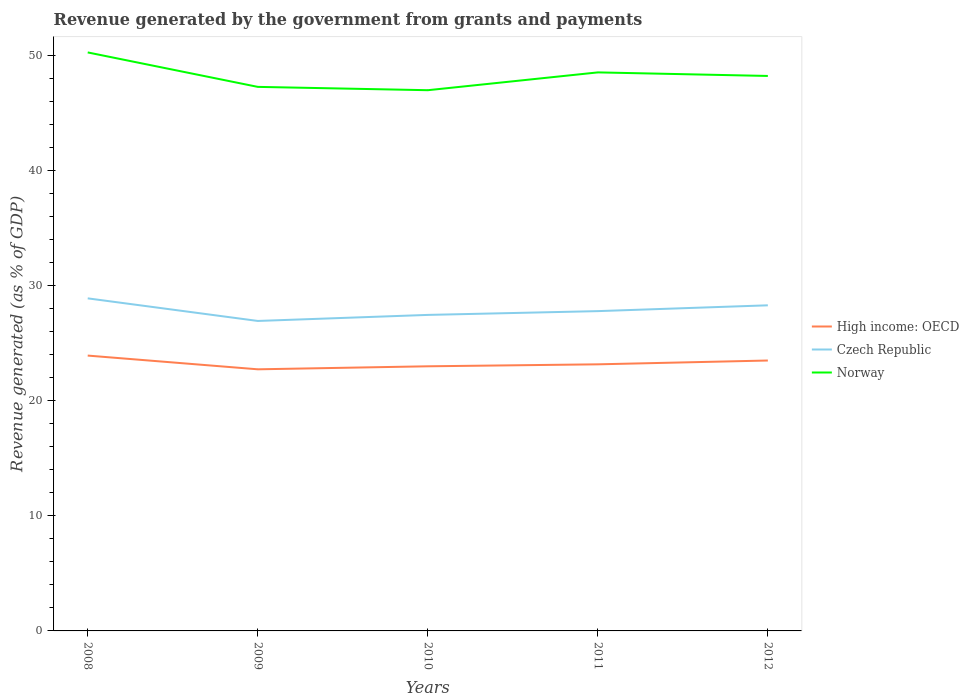Is the number of lines equal to the number of legend labels?
Make the answer very short. Yes. Across all years, what is the maximum revenue generated by the government in Norway?
Your answer should be very brief. 46.94. What is the total revenue generated by the government in Czech Republic in the graph?
Ensure brevity in your answer.  1.11. What is the difference between the highest and the second highest revenue generated by the government in High income: OECD?
Offer a terse response. 1.19. What is the difference between the highest and the lowest revenue generated by the government in Norway?
Your answer should be very brief. 2. Is the revenue generated by the government in Czech Republic strictly greater than the revenue generated by the government in High income: OECD over the years?
Ensure brevity in your answer.  No. How many lines are there?
Your answer should be compact. 3. How many years are there in the graph?
Ensure brevity in your answer.  5. Are the values on the major ticks of Y-axis written in scientific E-notation?
Provide a succinct answer. No. Does the graph contain grids?
Keep it short and to the point. No. How are the legend labels stacked?
Ensure brevity in your answer.  Vertical. What is the title of the graph?
Keep it short and to the point. Revenue generated by the government from grants and payments. Does "Korea (Democratic)" appear as one of the legend labels in the graph?
Provide a short and direct response. No. What is the label or title of the X-axis?
Your response must be concise. Years. What is the label or title of the Y-axis?
Offer a very short reply. Revenue generated (as % of GDP). What is the Revenue generated (as % of GDP) of High income: OECD in 2008?
Keep it short and to the point. 23.9. What is the Revenue generated (as % of GDP) of Czech Republic in 2008?
Your answer should be very brief. 28.87. What is the Revenue generated (as % of GDP) of Norway in 2008?
Provide a short and direct response. 50.23. What is the Revenue generated (as % of GDP) in High income: OECD in 2009?
Your response must be concise. 22.71. What is the Revenue generated (as % of GDP) of Czech Republic in 2009?
Ensure brevity in your answer.  26.91. What is the Revenue generated (as % of GDP) in Norway in 2009?
Offer a very short reply. 47.23. What is the Revenue generated (as % of GDP) of High income: OECD in 2010?
Your answer should be very brief. 22.97. What is the Revenue generated (as % of GDP) of Czech Republic in 2010?
Ensure brevity in your answer.  27.44. What is the Revenue generated (as % of GDP) of Norway in 2010?
Provide a succinct answer. 46.94. What is the Revenue generated (as % of GDP) in High income: OECD in 2011?
Your response must be concise. 23.15. What is the Revenue generated (as % of GDP) of Czech Republic in 2011?
Give a very brief answer. 27.76. What is the Revenue generated (as % of GDP) in Norway in 2011?
Ensure brevity in your answer.  48.49. What is the Revenue generated (as % of GDP) in High income: OECD in 2012?
Your answer should be very brief. 23.48. What is the Revenue generated (as % of GDP) of Czech Republic in 2012?
Ensure brevity in your answer.  28.27. What is the Revenue generated (as % of GDP) in Norway in 2012?
Provide a succinct answer. 48.18. Across all years, what is the maximum Revenue generated (as % of GDP) of High income: OECD?
Ensure brevity in your answer.  23.9. Across all years, what is the maximum Revenue generated (as % of GDP) in Czech Republic?
Your answer should be compact. 28.87. Across all years, what is the maximum Revenue generated (as % of GDP) in Norway?
Ensure brevity in your answer.  50.23. Across all years, what is the minimum Revenue generated (as % of GDP) of High income: OECD?
Your response must be concise. 22.71. Across all years, what is the minimum Revenue generated (as % of GDP) of Czech Republic?
Your response must be concise. 26.91. Across all years, what is the minimum Revenue generated (as % of GDP) in Norway?
Provide a short and direct response. 46.94. What is the total Revenue generated (as % of GDP) in High income: OECD in the graph?
Offer a terse response. 116.21. What is the total Revenue generated (as % of GDP) of Czech Republic in the graph?
Your answer should be compact. 139.26. What is the total Revenue generated (as % of GDP) of Norway in the graph?
Keep it short and to the point. 241.08. What is the difference between the Revenue generated (as % of GDP) in High income: OECD in 2008 and that in 2009?
Your answer should be compact. 1.19. What is the difference between the Revenue generated (as % of GDP) in Czech Republic in 2008 and that in 2009?
Keep it short and to the point. 1.96. What is the difference between the Revenue generated (as % of GDP) in Norway in 2008 and that in 2009?
Offer a terse response. 2.99. What is the difference between the Revenue generated (as % of GDP) in High income: OECD in 2008 and that in 2010?
Provide a short and direct response. 0.93. What is the difference between the Revenue generated (as % of GDP) of Czech Republic in 2008 and that in 2010?
Offer a very short reply. 1.44. What is the difference between the Revenue generated (as % of GDP) of Norway in 2008 and that in 2010?
Your response must be concise. 3.28. What is the difference between the Revenue generated (as % of GDP) of High income: OECD in 2008 and that in 2011?
Give a very brief answer. 0.76. What is the difference between the Revenue generated (as % of GDP) in Czech Republic in 2008 and that in 2011?
Keep it short and to the point. 1.11. What is the difference between the Revenue generated (as % of GDP) of Norway in 2008 and that in 2011?
Provide a short and direct response. 1.73. What is the difference between the Revenue generated (as % of GDP) of High income: OECD in 2008 and that in 2012?
Your response must be concise. 0.43. What is the difference between the Revenue generated (as % of GDP) in Czech Republic in 2008 and that in 2012?
Your answer should be very brief. 0.6. What is the difference between the Revenue generated (as % of GDP) in Norway in 2008 and that in 2012?
Provide a short and direct response. 2.04. What is the difference between the Revenue generated (as % of GDP) of High income: OECD in 2009 and that in 2010?
Offer a very short reply. -0.26. What is the difference between the Revenue generated (as % of GDP) in Czech Republic in 2009 and that in 2010?
Your answer should be compact. -0.53. What is the difference between the Revenue generated (as % of GDP) of Norway in 2009 and that in 2010?
Provide a short and direct response. 0.29. What is the difference between the Revenue generated (as % of GDP) in High income: OECD in 2009 and that in 2011?
Your answer should be very brief. -0.43. What is the difference between the Revenue generated (as % of GDP) in Czech Republic in 2009 and that in 2011?
Ensure brevity in your answer.  -0.85. What is the difference between the Revenue generated (as % of GDP) of Norway in 2009 and that in 2011?
Provide a succinct answer. -1.26. What is the difference between the Revenue generated (as % of GDP) in High income: OECD in 2009 and that in 2012?
Provide a succinct answer. -0.76. What is the difference between the Revenue generated (as % of GDP) of Czech Republic in 2009 and that in 2012?
Keep it short and to the point. -1.36. What is the difference between the Revenue generated (as % of GDP) in Norway in 2009 and that in 2012?
Offer a terse response. -0.95. What is the difference between the Revenue generated (as % of GDP) of High income: OECD in 2010 and that in 2011?
Provide a succinct answer. -0.17. What is the difference between the Revenue generated (as % of GDP) in Czech Republic in 2010 and that in 2011?
Make the answer very short. -0.33. What is the difference between the Revenue generated (as % of GDP) in Norway in 2010 and that in 2011?
Ensure brevity in your answer.  -1.55. What is the difference between the Revenue generated (as % of GDP) in High income: OECD in 2010 and that in 2012?
Your answer should be compact. -0.5. What is the difference between the Revenue generated (as % of GDP) in Czech Republic in 2010 and that in 2012?
Your answer should be compact. -0.83. What is the difference between the Revenue generated (as % of GDP) of Norway in 2010 and that in 2012?
Give a very brief answer. -1.24. What is the difference between the Revenue generated (as % of GDP) of High income: OECD in 2011 and that in 2012?
Your answer should be compact. -0.33. What is the difference between the Revenue generated (as % of GDP) of Czech Republic in 2011 and that in 2012?
Provide a succinct answer. -0.51. What is the difference between the Revenue generated (as % of GDP) of Norway in 2011 and that in 2012?
Your answer should be very brief. 0.31. What is the difference between the Revenue generated (as % of GDP) in High income: OECD in 2008 and the Revenue generated (as % of GDP) in Czech Republic in 2009?
Your answer should be very brief. -3.01. What is the difference between the Revenue generated (as % of GDP) in High income: OECD in 2008 and the Revenue generated (as % of GDP) in Norway in 2009?
Provide a short and direct response. -23.33. What is the difference between the Revenue generated (as % of GDP) of Czech Republic in 2008 and the Revenue generated (as % of GDP) of Norway in 2009?
Offer a terse response. -18.36. What is the difference between the Revenue generated (as % of GDP) of High income: OECD in 2008 and the Revenue generated (as % of GDP) of Czech Republic in 2010?
Offer a very short reply. -3.53. What is the difference between the Revenue generated (as % of GDP) of High income: OECD in 2008 and the Revenue generated (as % of GDP) of Norway in 2010?
Your response must be concise. -23.04. What is the difference between the Revenue generated (as % of GDP) in Czech Republic in 2008 and the Revenue generated (as % of GDP) in Norway in 2010?
Offer a very short reply. -18.07. What is the difference between the Revenue generated (as % of GDP) in High income: OECD in 2008 and the Revenue generated (as % of GDP) in Czech Republic in 2011?
Give a very brief answer. -3.86. What is the difference between the Revenue generated (as % of GDP) in High income: OECD in 2008 and the Revenue generated (as % of GDP) in Norway in 2011?
Ensure brevity in your answer.  -24.59. What is the difference between the Revenue generated (as % of GDP) of Czech Republic in 2008 and the Revenue generated (as % of GDP) of Norway in 2011?
Make the answer very short. -19.62. What is the difference between the Revenue generated (as % of GDP) of High income: OECD in 2008 and the Revenue generated (as % of GDP) of Czech Republic in 2012?
Provide a short and direct response. -4.36. What is the difference between the Revenue generated (as % of GDP) of High income: OECD in 2008 and the Revenue generated (as % of GDP) of Norway in 2012?
Offer a very short reply. -24.28. What is the difference between the Revenue generated (as % of GDP) in Czech Republic in 2008 and the Revenue generated (as % of GDP) in Norway in 2012?
Ensure brevity in your answer.  -19.31. What is the difference between the Revenue generated (as % of GDP) of High income: OECD in 2009 and the Revenue generated (as % of GDP) of Czech Republic in 2010?
Keep it short and to the point. -4.72. What is the difference between the Revenue generated (as % of GDP) in High income: OECD in 2009 and the Revenue generated (as % of GDP) in Norway in 2010?
Provide a succinct answer. -24.23. What is the difference between the Revenue generated (as % of GDP) of Czech Republic in 2009 and the Revenue generated (as % of GDP) of Norway in 2010?
Your response must be concise. -20.03. What is the difference between the Revenue generated (as % of GDP) of High income: OECD in 2009 and the Revenue generated (as % of GDP) of Czech Republic in 2011?
Provide a succinct answer. -5.05. What is the difference between the Revenue generated (as % of GDP) in High income: OECD in 2009 and the Revenue generated (as % of GDP) in Norway in 2011?
Offer a very short reply. -25.78. What is the difference between the Revenue generated (as % of GDP) of Czech Republic in 2009 and the Revenue generated (as % of GDP) of Norway in 2011?
Give a very brief answer. -21.58. What is the difference between the Revenue generated (as % of GDP) of High income: OECD in 2009 and the Revenue generated (as % of GDP) of Czech Republic in 2012?
Offer a very short reply. -5.56. What is the difference between the Revenue generated (as % of GDP) in High income: OECD in 2009 and the Revenue generated (as % of GDP) in Norway in 2012?
Provide a short and direct response. -25.47. What is the difference between the Revenue generated (as % of GDP) in Czech Republic in 2009 and the Revenue generated (as % of GDP) in Norway in 2012?
Provide a succinct answer. -21.27. What is the difference between the Revenue generated (as % of GDP) in High income: OECD in 2010 and the Revenue generated (as % of GDP) in Czech Republic in 2011?
Keep it short and to the point. -4.79. What is the difference between the Revenue generated (as % of GDP) in High income: OECD in 2010 and the Revenue generated (as % of GDP) in Norway in 2011?
Provide a short and direct response. -25.52. What is the difference between the Revenue generated (as % of GDP) of Czech Republic in 2010 and the Revenue generated (as % of GDP) of Norway in 2011?
Keep it short and to the point. -21.05. What is the difference between the Revenue generated (as % of GDP) in High income: OECD in 2010 and the Revenue generated (as % of GDP) in Czech Republic in 2012?
Offer a very short reply. -5.3. What is the difference between the Revenue generated (as % of GDP) in High income: OECD in 2010 and the Revenue generated (as % of GDP) in Norway in 2012?
Ensure brevity in your answer.  -25.21. What is the difference between the Revenue generated (as % of GDP) of Czech Republic in 2010 and the Revenue generated (as % of GDP) of Norway in 2012?
Provide a succinct answer. -20.75. What is the difference between the Revenue generated (as % of GDP) of High income: OECD in 2011 and the Revenue generated (as % of GDP) of Czech Republic in 2012?
Make the answer very short. -5.12. What is the difference between the Revenue generated (as % of GDP) of High income: OECD in 2011 and the Revenue generated (as % of GDP) of Norway in 2012?
Give a very brief answer. -25.04. What is the difference between the Revenue generated (as % of GDP) in Czech Republic in 2011 and the Revenue generated (as % of GDP) in Norway in 2012?
Offer a terse response. -20.42. What is the average Revenue generated (as % of GDP) of High income: OECD per year?
Offer a very short reply. 23.24. What is the average Revenue generated (as % of GDP) of Czech Republic per year?
Give a very brief answer. 27.85. What is the average Revenue generated (as % of GDP) of Norway per year?
Your answer should be compact. 48.22. In the year 2008, what is the difference between the Revenue generated (as % of GDP) of High income: OECD and Revenue generated (as % of GDP) of Czech Republic?
Provide a short and direct response. -4.97. In the year 2008, what is the difference between the Revenue generated (as % of GDP) of High income: OECD and Revenue generated (as % of GDP) of Norway?
Ensure brevity in your answer.  -26.32. In the year 2008, what is the difference between the Revenue generated (as % of GDP) in Czech Republic and Revenue generated (as % of GDP) in Norway?
Ensure brevity in your answer.  -21.35. In the year 2009, what is the difference between the Revenue generated (as % of GDP) in High income: OECD and Revenue generated (as % of GDP) in Czech Republic?
Make the answer very short. -4.2. In the year 2009, what is the difference between the Revenue generated (as % of GDP) in High income: OECD and Revenue generated (as % of GDP) in Norway?
Offer a very short reply. -24.52. In the year 2009, what is the difference between the Revenue generated (as % of GDP) of Czech Republic and Revenue generated (as % of GDP) of Norway?
Give a very brief answer. -20.32. In the year 2010, what is the difference between the Revenue generated (as % of GDP) of High income: OECD and Revenue generated (as % of GDP) of Czech Republic?
Offer a very short reply. -4.46. In the year 2010, what is the difference between the Revenue generated (as % of GDP) in High income: OECD and Revenue generated (as % of GDP) in Norway?
Provide a succinct answer. -23.97. In the year 2010, what is the difference between the Revenue generated (as % of GDP) of Czech Republic and Revenue generated (as % of GDP) of Norway?
Ensure brevity in your answer.  -19.51. In the year 2011, what is the difference between the Revenue generated (as % of GDP) in High income: OECD and Revenue generated (as % of GDP) in Czech Republic?
Offer a very short reply. -4.62. In the year 2011, what is the difference between the Revenue generated (as % of GDP) of High income: OECD and Revenue generated (as % of GDP) of Norway?
Provide a succinct answer. -25.35. In the year 2011, what is the difference between the Revenue generated (as % of GDP) in Czech Republic and Revenue generated (as % of GDP) in Norway?
Make the answer very short. -20.73. In the year 2012, what is the difference between the Revenue generated (as % of GDP) in High income: OECD and Revenue generated (as % of GDP) in Czech Republic?
Keep it short and to the point. -4.79. In the year 2012, what is the difference between the Revenue generated (as % of GDP) in High income: OECD and Revenue generated (as % of GDP) in Norway?
Offer a very short reply. -24.71. In the year 2012, what is the difference between the Revenue generated (as % of GDP) in Czech Republic and Revenue generated (as % of GDP) in Norway?
Offer a terse response. -19.91. What is the ratio of the Revenue generated (as % of GDP) of High income: OECD in 2008 to that in 2009?
Ensure brevity in your answer.  1.05. What is the ratio of the Revenue generated (as % of GDP) in Czech Republic in 2008 to that in 2009?
Give a very brief answer. 1.07. What is the ratio of the Revenue generated (as % of GDP) in Norway in 2008 to that in 2009?
Keep it short and to the point. 1.06. What is the ratio of the Revenue generated (as % of GDP) of High income: OECD in 2008 to that in 2010?
Offer a very short reply. 1.04. What is the ratio of the Revenue generated (as % of GDP) of Czech Republic in 2008 to that in 2010?
Your answer should be very brief. 1.05. What is the ratio of the Revenue generated (as % of GDP) in Norway in 2008 to that in 2010?
Offer a terse response. 1.07. What is the ratio of the Revenue generated (as % of GDP) of High income: OECD in 2008 to that in 2011?
Provide a short and direct response. 1.03. What is the ratio of the Revenue generated (as % of GDP) of Czech Republic in 2008 to that in 2011?
Make the answer very short. 1.04. What is the ratio of the Revenue generated (as % of GDP) of Norway in 2008 to that in 2011?
Make the answer very short. 1.04. What is the ratio of the Revenue generated (as % of GDP) in High income: OECD in 2008 to that in 2012?
Provide a short and direct response. 1.02. What is the ratio of the Revenue generated (as % of GDP) of Czech Republic in 2008 to that in 2012?
Your answer should be compact. 1.02. What is the ratio of the Revenue generated (as % of GDP) in Norway in 2008 to that in 2012?
Offer a terse response. 1.04. What is the ratio of the Revenue generated (as % of GDP) of Czech Republic in 2009 to that in 2010?
Ensure brevity in your answer.  0.98. What is the ratio of the Revenue generated (as % of GDP) of High income: OECD in 2009 to that in 2011?
Provide a succinct answer. 0.98. What is the ratio of the Revenue generated (as % of GDP) in Czech Republic in 2009 to that in 2011?
Offer a very short reply. 0.97. What is the ratio of the Revenue generated (as % of GDP) in Norway in 2009 to that in 2011?
Make the answer very short. 0.97. What is the ratio of the Revenue generated (as % of GDP) in High income: OECD in 2009 to that in 2012?
Offer a terse response. 0.97. What is the ratio of the Revenue generated (as % of GDP) of Czech Republic in 2009 to that in 2012?
Make the answer very short. 0.95. What is the ratio of the Revenue generated (as % of GDP) in Norway in 2009 to that in 2012?
Your response must be concise. 0.98. What is the ratio of the Revenue generated (as % of GDP) of High income: OECD in 2010 to that in 2011?
Your response must be concise. 0.99. What is the ratio of the Revenue generated (as % of GDP) in Czech Republic in 2010 to that in 2011?
Provide a short and direct response. 0.99. What is the ratio of the Revenue generated (as % of GDP) of Norway in 2010 to that in 2011?
Your response must be concise. 0.97. What is the ratio of the Revenue generated (as % of GDP) of High income: OECD in 2010 to that in 2012?
Keep it short and to the point. 0.98. What is the ratio of the Revenue generated (as % of GDP) in Czech Republic in 2010 to that in 2012?
Provide a short and direct response. 0.97. What is the ratio of the Revenue generated (as % of GDP) of Norway in 2010 to that in 2012?
Give a very brief answer. 0.97. What is the ratio of the Revenue generated (as % of GDP) of High income: OECD in 2011 to that in 2012?
Offer a terse response. 0.99. What is the ratio of the Revenue generated (as % of GDP) of Czech Republic in 2011 to that in 2012?
Your response must be concise. 0.98. What is the ratio of the Revenue generated (as % of GDP) in Norway in 2011 to that in 2012?
Provide a short and direct response. 1.01. What is the difference between the highest and the second highest Revenue generated (as % of GDP) of High income: OECD?
Your answer should be compact. 0.43. What is the difference between the highest and the second highest Revenue generated (as % of GDP) of Czech Republic?
Your answer should be compact. 0.6. What is the difference between the highest and the second highest Revenue generated (as % of GDP) in Norway?
Provide a short and direct response. 1.73. What is the difference between the highest and the lowest Revenue generated (as % of GDP) in High income: OECD?
Your answer should be compact. 1.19. What is the difference between the highest and the lowest Revenue generated (as % of GDP) of Czech Republic?
Keep it short and to the point. 1.96. What is the difference between the highest and the lowest Revenue generated (as % of GDP) in Norway?
Make the answer very short. 3.28. 